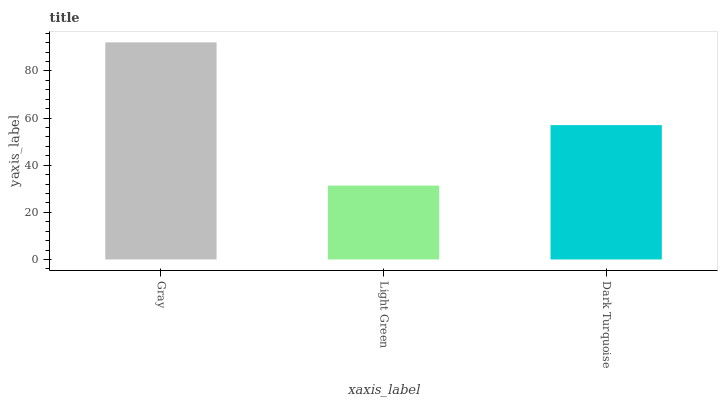Is Light Green the minimum?
Answer yes or no. Yes. Is Gray the maximum?
Answer yes or no. Yes. Is Dark Turquoise the minimum?
Answer yes or no. No. Is Dark Turquoise the maximum?
Answer yes or no. No. Is Dark Turquoise greater than Light Green?
Answer yes or no. Yes. Is Light Green less than Dark Turquoise?
Answer yes or no. Yes. Is Light Green greater than Dark Turquoise?
Answer yes or no. No. Is Dark Turquoise less than Light Green?
Answer yes or no. No. Is Dark Turquoise the high median?
Answer yes or no. Yes. Is Dark Turquoise the low median?
Answer yes or no. Yes. Is Gray the high median?
Answer yes or no. No. Is Light Green the low median?
Answer yes or no. No. 